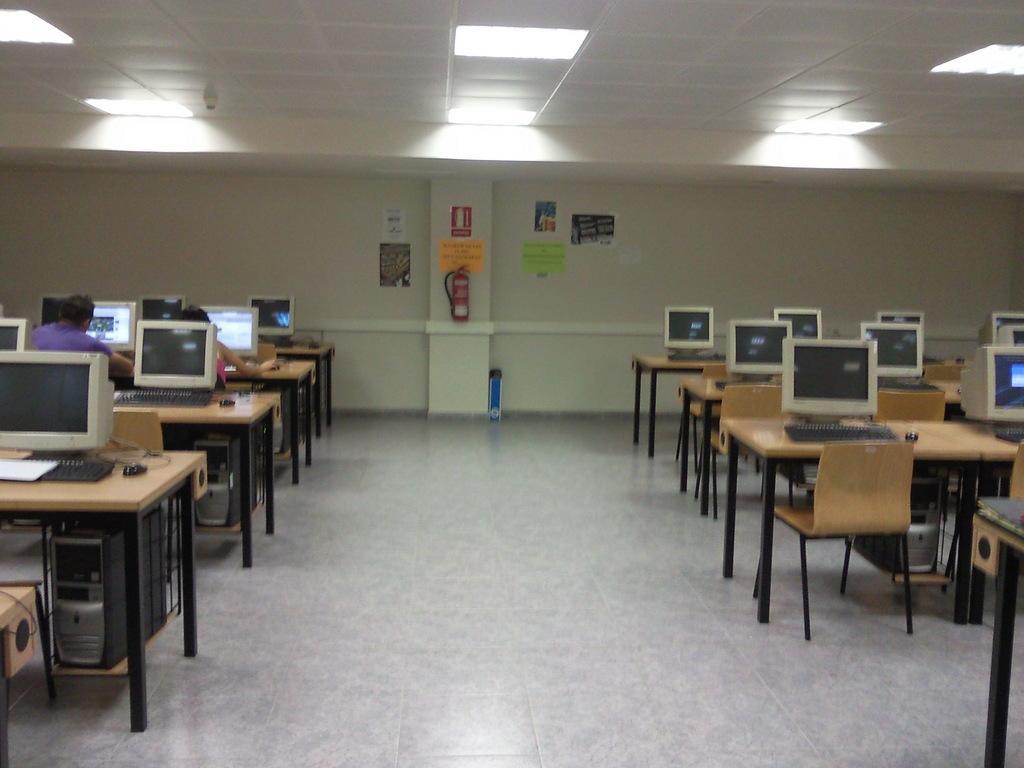Please provide a concise description of this image. On the right and left side of the image we can see monitor, keyboards, CPUs , tables and mouse. In the background we can see persons, wall, fire extinguisher and posters. 